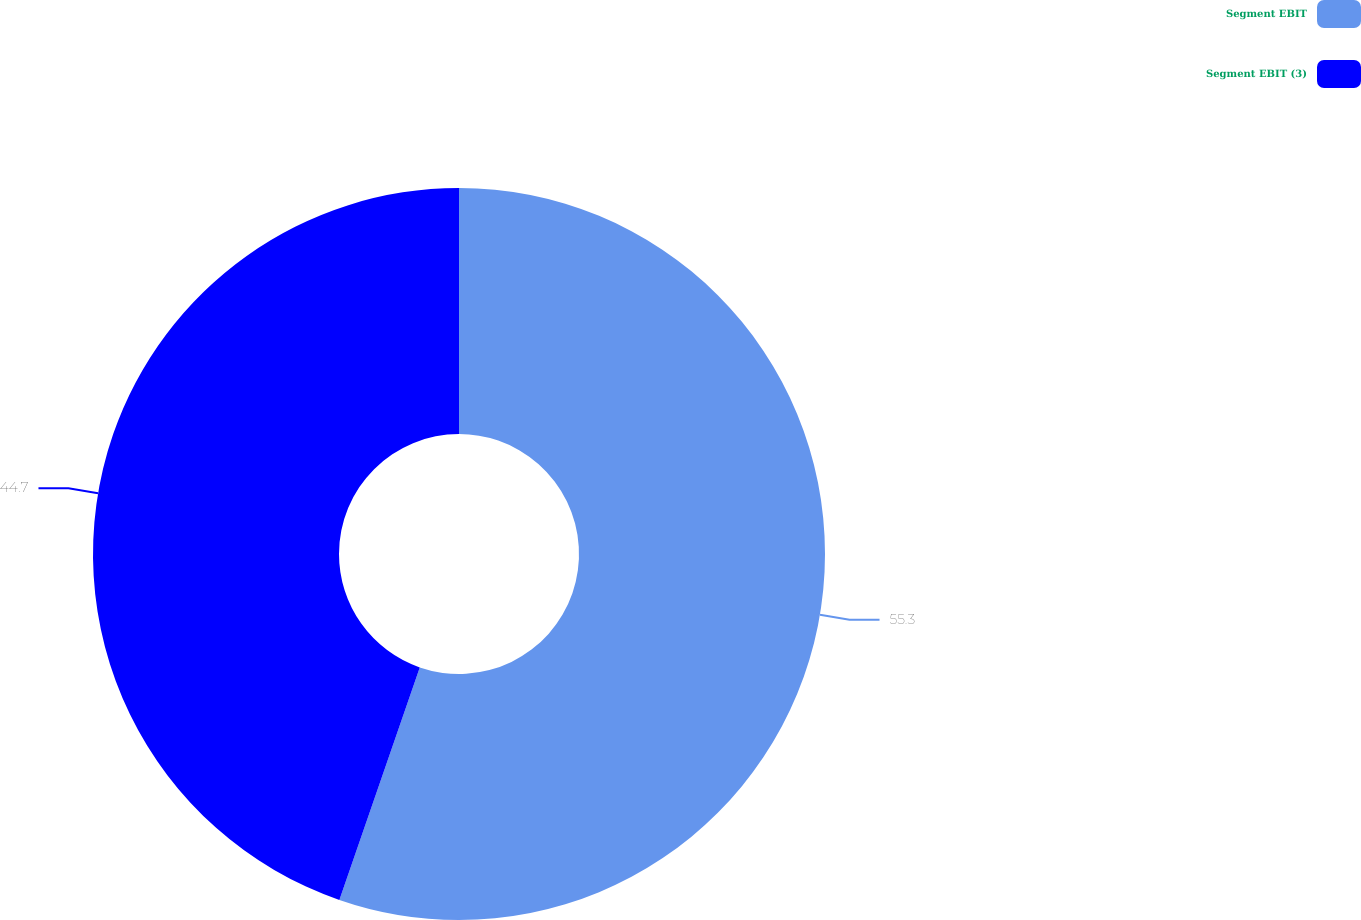Convert chart. <chart><loc_0><loc_0><loc_500><loc_500><pie_chart><fcel>Segment EBIT<fcel>Segment EBIT (3)<nl><fcel>55.3%<fcel>44.7%<nl></chart> 